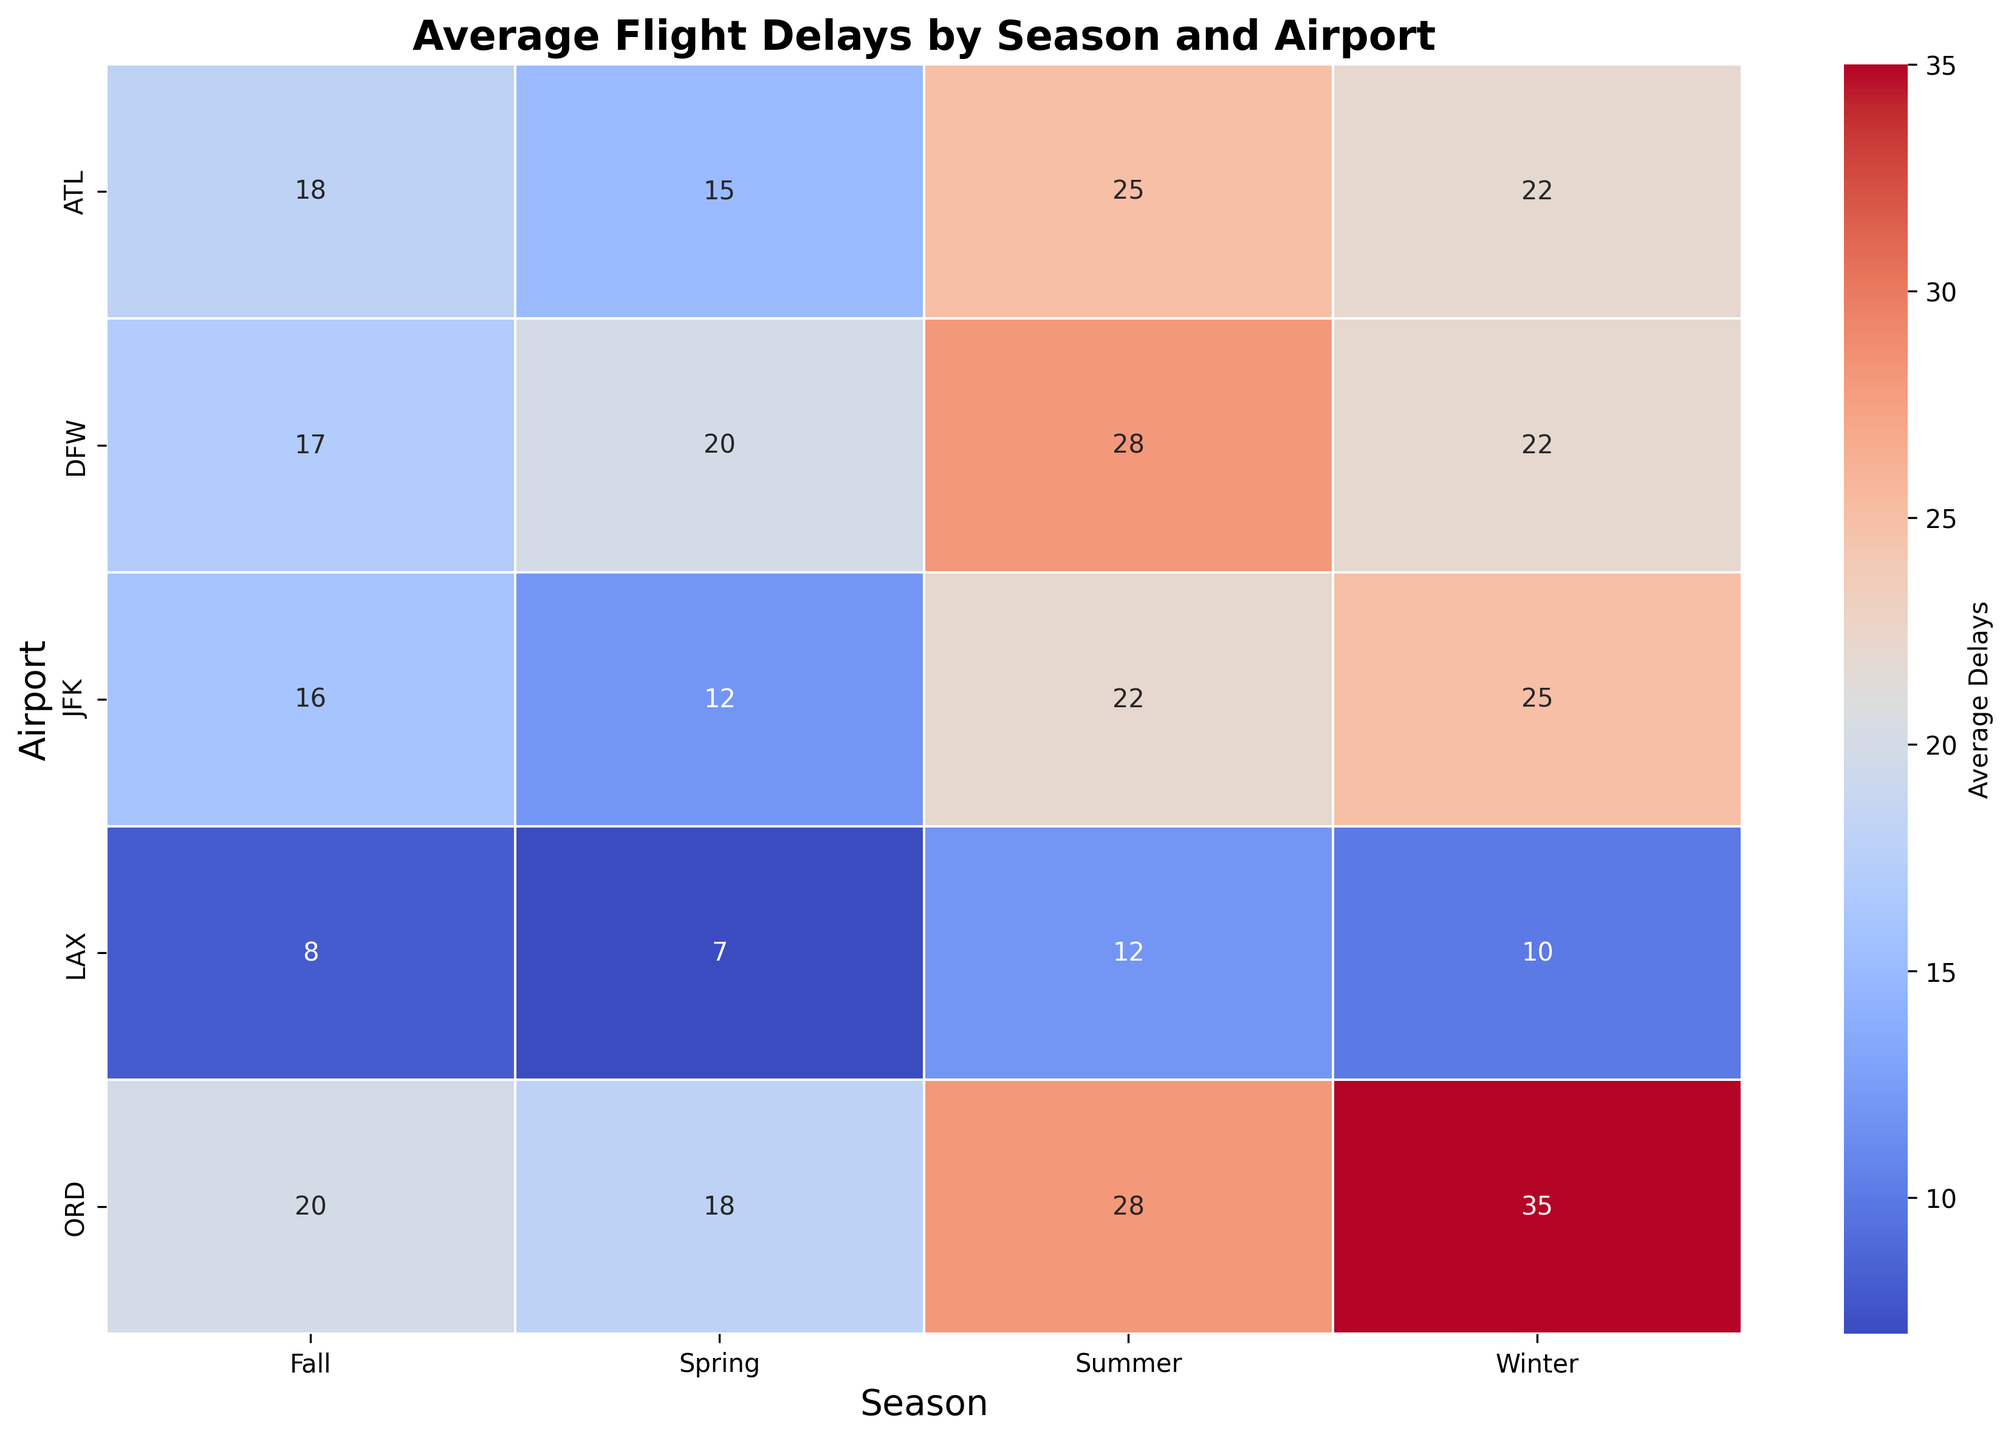What season has the highest average flight delays at ORD? Observing ORD row, the highest value in the "Average Delays" is in the Winter column.
Answer: Winter Which airport has the least average flight delays in the Summer? Comparing the values in the Summer column, LAX has the lowest value of 12.
Answer: LAX What is the difference in average flight delays between ATL and JFK during Winter? In the Winter column, the values for ATL and JFK are 22 and 25, respectively. The difference is 25 - 22.
Answer: 3 Which season generally causes more delays across all airports, Spring or Fall? Summing average delays for Spring and Fall across all airports: (15 + 7 + 18 + 12 + 20) for Spring and (18 + 8 + 20 + 16 + 17) for Fall. Spring = 15 + 7 + 18 + 12 + 20 = 72, Fall = 18 + 8 + 20 + 16 + 17 = 79.
Answer: Fall Which airport's flights are most affected by delays in Winter? Checking the Winter column, ORD has the highest value of 35.
Answer: ORD Compare the average delays at LAX between Spring and Winter. Which season has fewer delays? Observing LAX row, Spring has 7 delays and Winter has 10 delays.
Answer: Spring Across all airports, are flight delays higher on average in Summer or Winter? Calculating the average of Summer and Winter delays across all airports: (25 + 12 + 28 + 22 + 28) for Summer and (22 + 10 + 35 + 25 + 22) for Winter. Average for Summer = (25 + 12 + 28 + 22 + 28)/5 = 23, Average for Winter = (22 + 10 + 35 + 25 + 22)/5 = 22.6.
Answer: Summer What is the range of average delays for DFW throughout the year? Observing DFW row, the range is calculated as max value - min value = 28 (Summer) - 17 (Fall).
Answer: 11 